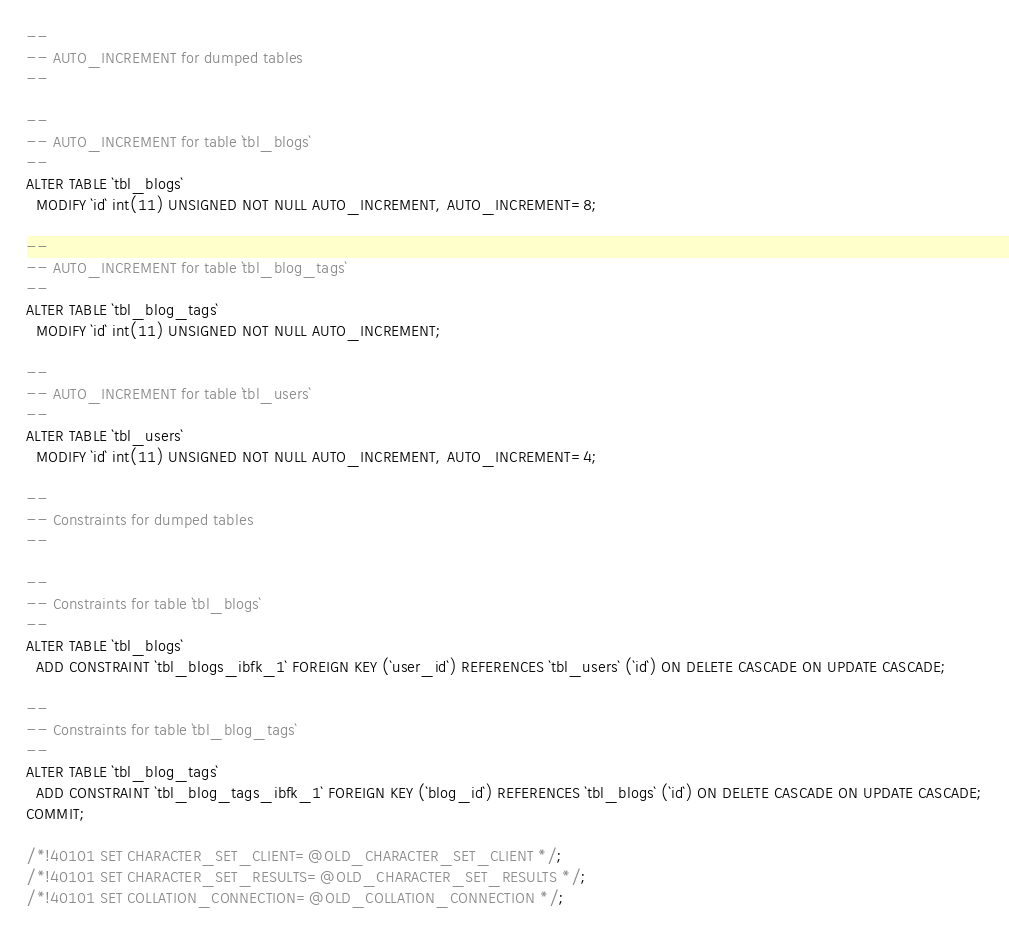<code> <loc_0><loc_0><loc_500><loc_500><_SQL_>--
-- AUTO_INCREMENT for dumped tables
--

--
-- AUTO_INCREMENT for table `tbl_blogs`
--
ALTER TABLE `tbl_blogs`
  MODIFY `id` int(11) UNSIGNED NOT NULL AUTO_INCREMENT, AUTO_INCREMENT=8;

--
-- AUTO_INCREMENT for table `tbl_blog_tags`
--
ALTER TABLE `tbl_blog_tags`
  MODIFY `id` int(11) UNSIGNED NOT NULL AUTO_INCREMENT;

--
-- AUTO_INCREMENT for table `tbl_users`
--
ALTER TABLE `tbl_users`
  MODIFY `id` int(11) UNSIGNED NOT NULL AUTO_INCREMENT, AUTO_INCREMENT=4;

--
-- Constraints for dumped tables
--

--
-- Constraints for table `tbl_blogs`
--
ALTER TABLE `tbl_blogs`
  ADD CONSTRAINT `tbl_blogs_ibfk_1` FOREIGN KEY (`user_id`) REFERENCES `tbl_users` (`id`) ON DELETE CASCADE ON UPDATE CASCADE;

--
-- Constraints for table `tbl_blog_tags`
--
ALTER TABLE `tbl_blog_tags`
  ADD CONSTRAINT `tbl_blog_tags_ibfk_1` FOREIGN KEY (`blog_id`) REFERENCES `tbl_blogs` (`id`) ON DELETE CASCADE ON UPDATE CASCADE;
COMMIT;

/*!40101 SET CHARACTER_SET_CLIENT=@OLD_CHARACTER_SET_CLIENT */;
/*!40101 SET CHARACTER_SET_RESULTS=@OLD_CHARACTER_SET_RESULTS */;
/*!40101 SET COLLATION_CONNECTION=@OLD_COLLATION_CONNECTION */;
</code> 